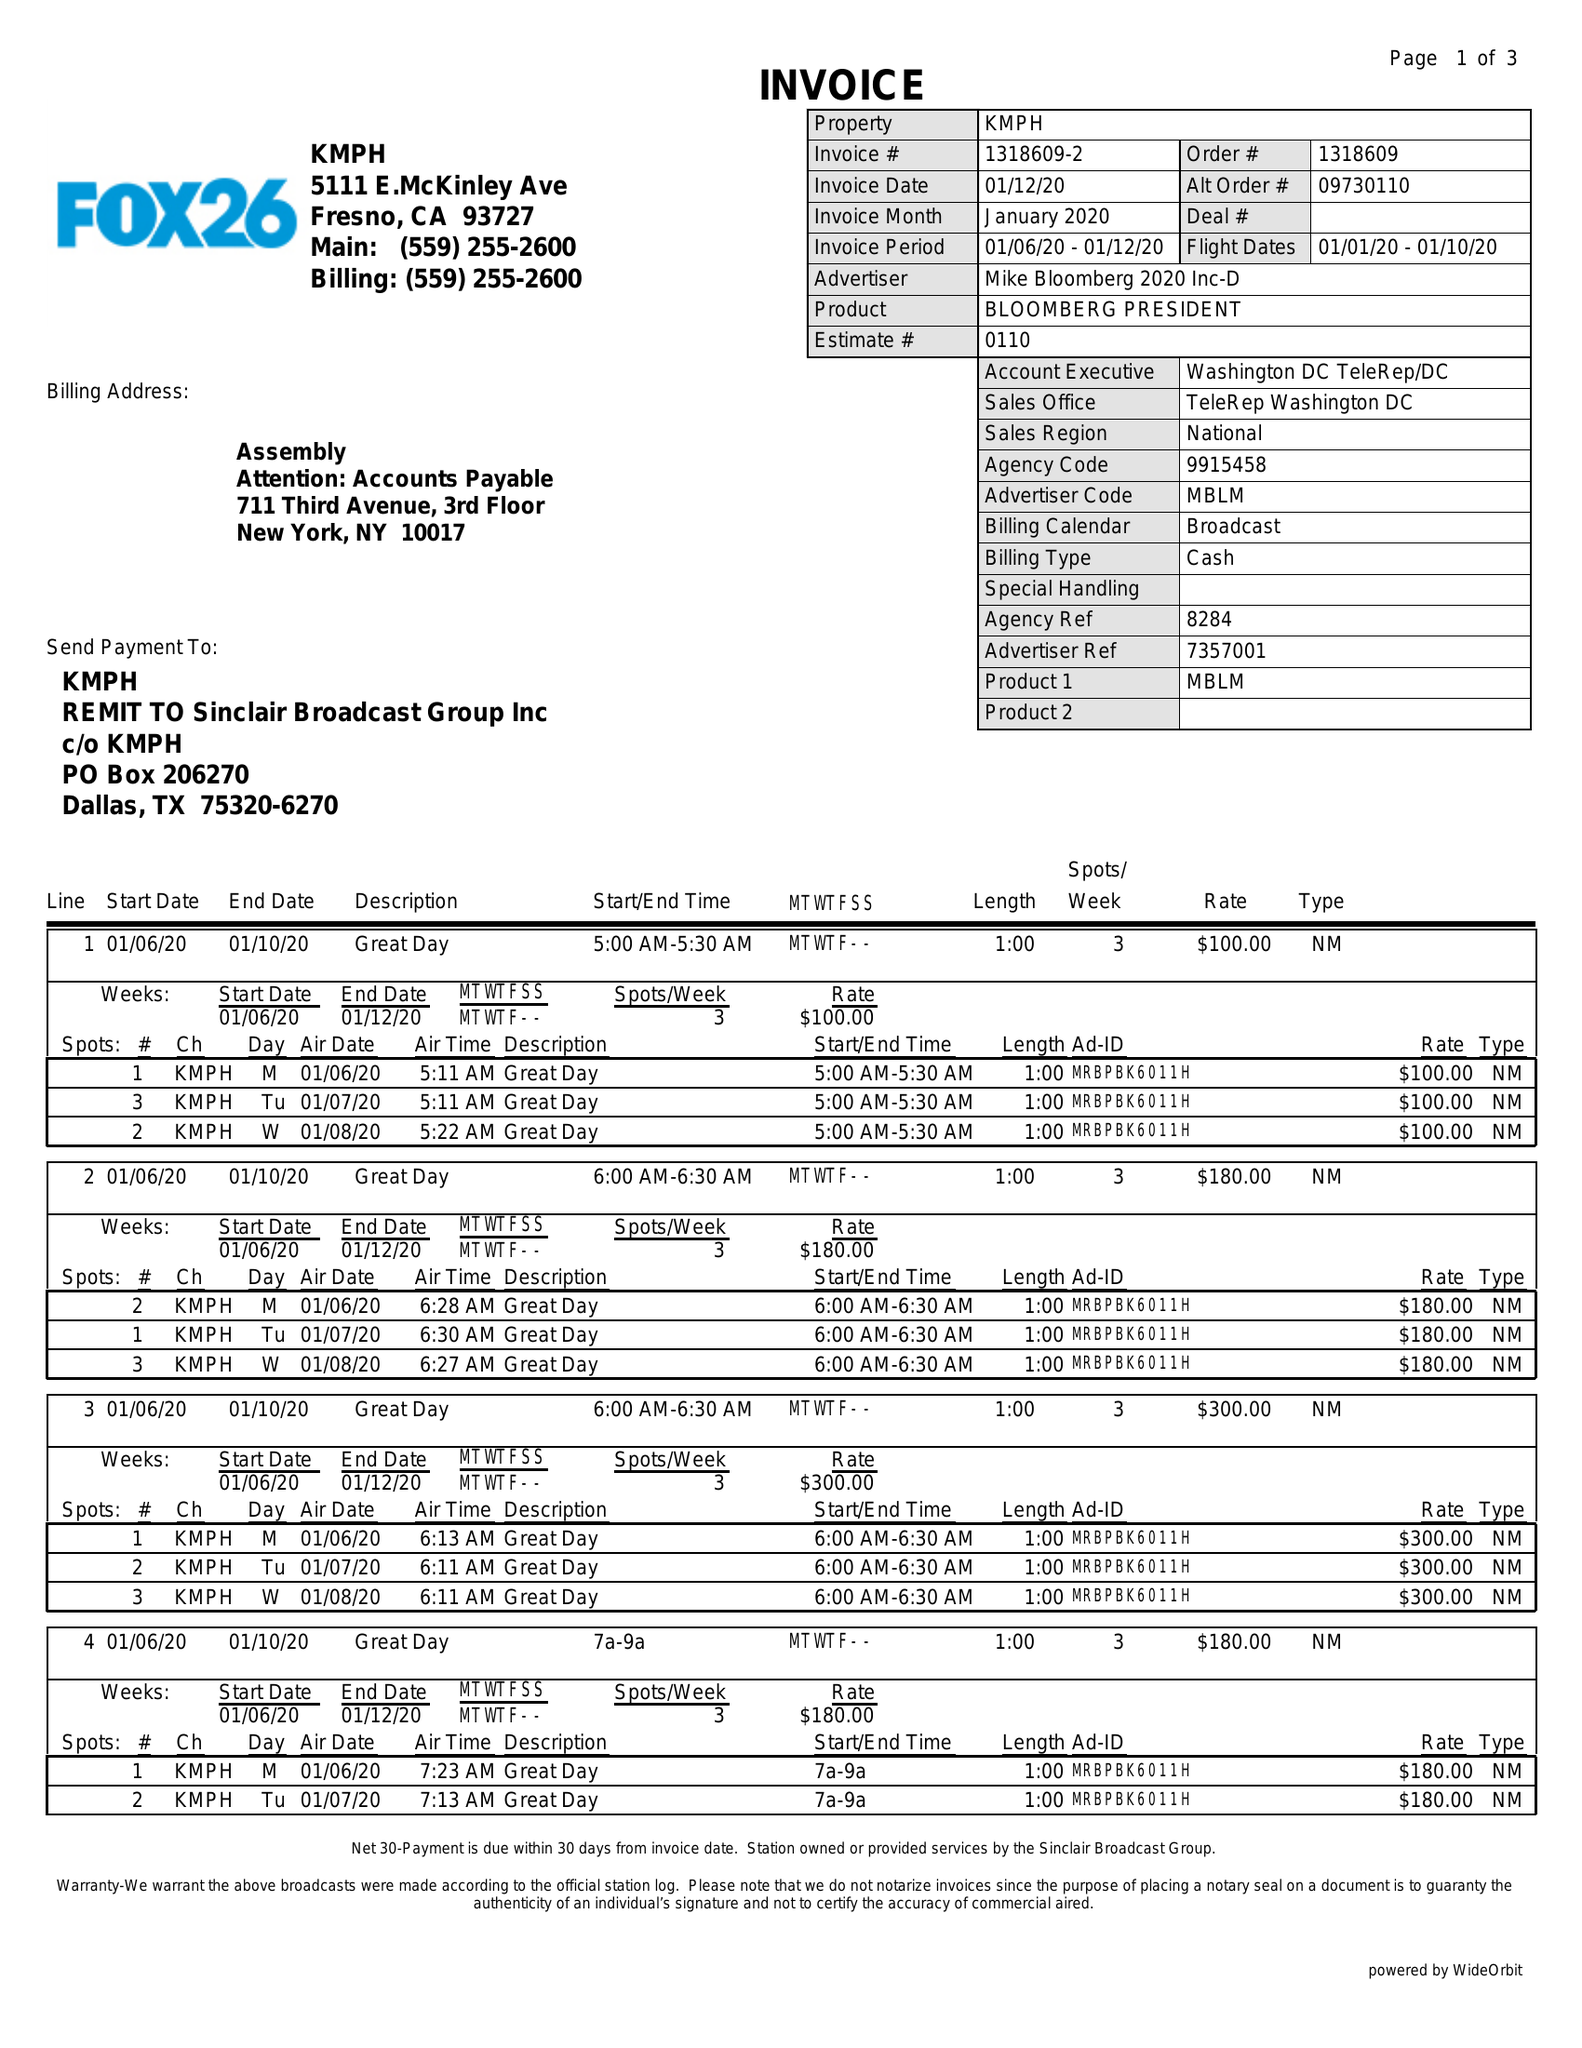What is the value for the flight_to?
Answer the question using a single word or phrase. 01/10/20 